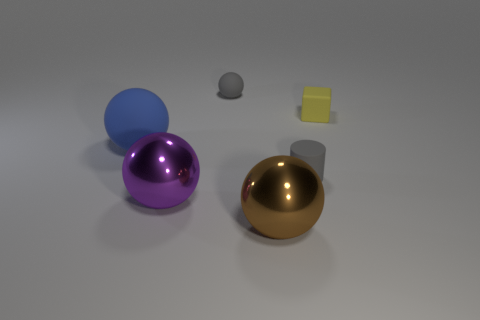What is the shape of the gray matte object that is behind the big thing that is to the left of the shiny sphere on the left side of the gray ball?
Provide a short and direct response. Sphere. Is there any other thing that has the same material as the large blue object?
Your response must be concise. Yes. What is the size of the gray rubber object that is the same shape as the brown thing?
Ensure brevity in your answer.  Small. The small object that is both in front of the gray matte ball and behind the blue object is what color?
Your response must be concise. Yellow. Are the block and the large sphere on the right side of the big purple thing made of the same material?
Offer a terse response. No. Is the number of yellow things that are right of the small yellow rubber cube less than the number of large cyan cylinders?
Your answer should be very brief. No. How many other things are the same shape as the large brown thing?
Keep it short and to the point. 3. Are there any other things that have the same color as the big matte ball?
Your response must be concise. No. There is a big matte ball; is its color the same as the tiny thing behind the yellow block?
Provide a succinct answer. No. How many other objects are there of the same size as the brown metallic object?
Your response must be concise. 2. 